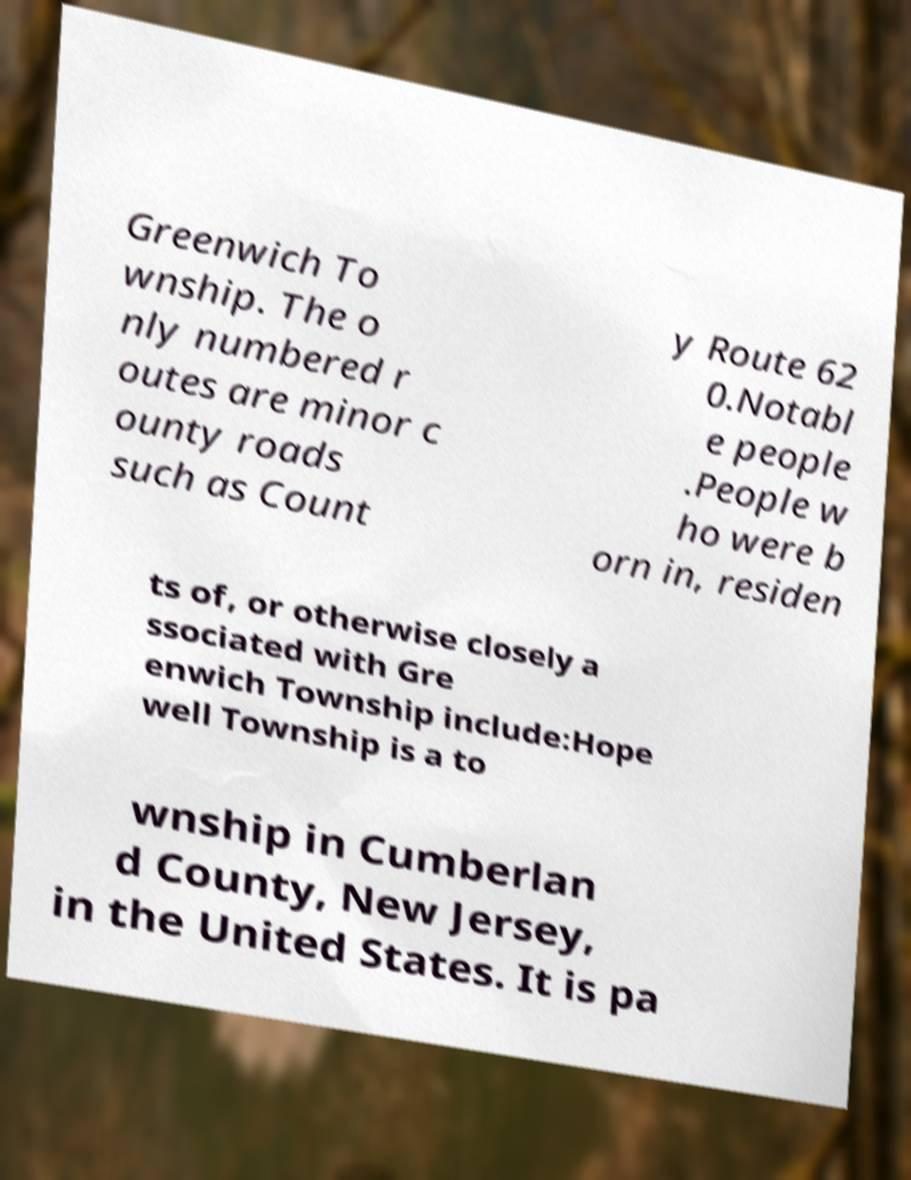Please read and relay the text visible in this image. What does it say? Greenwich To wnship. The o nly numbered r outes are minor c ounty roads such as Count y Route 62 0.Notabl e people .People w ho were b orn in, residen ts of, or otherwise closely a ssociated with Gre enwich Township include:Hope well Township is a to wnship in Cumberlan d County, New Jersey, in the United States. It is pa 